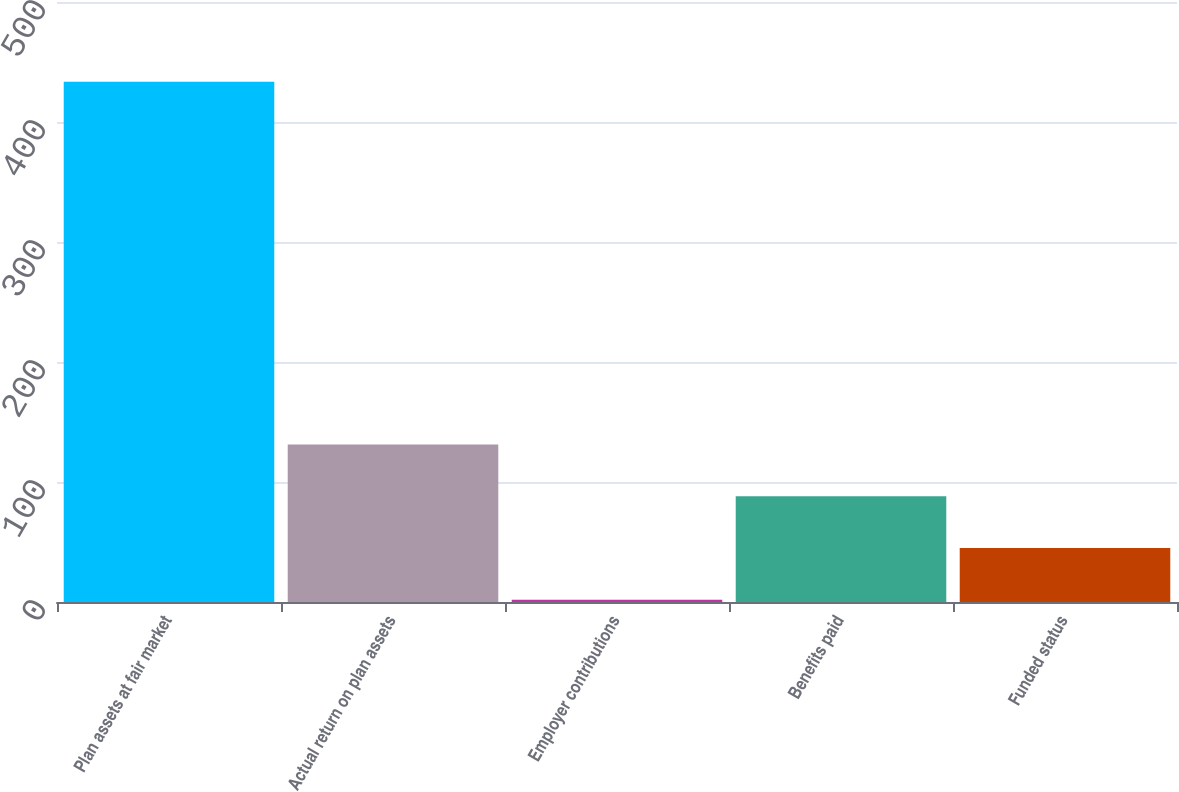Convert chart to OTSL. <chart><loc_0><loc_0><loc_500><loc_500><bar_chart><fcel>Plan assets at fair market<fcel>Actual return on plan assets<fcel>Employer contributions<fcel>Benefits paid<fcel>Funded status<nl><fcel>433.6<fcel>131.34<fcel>1.8<fcel>88.16<fcel>44.98<nl></chart> 